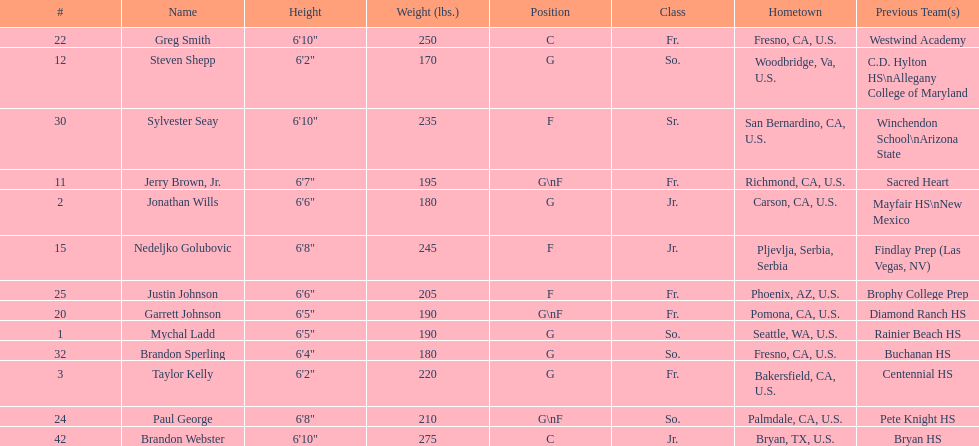Which positions are so.? G, G, G\nF, G. Which weights are g 190, 170, 180. What height is under 6 3' 6'2". What is the name Steven Shepp. 